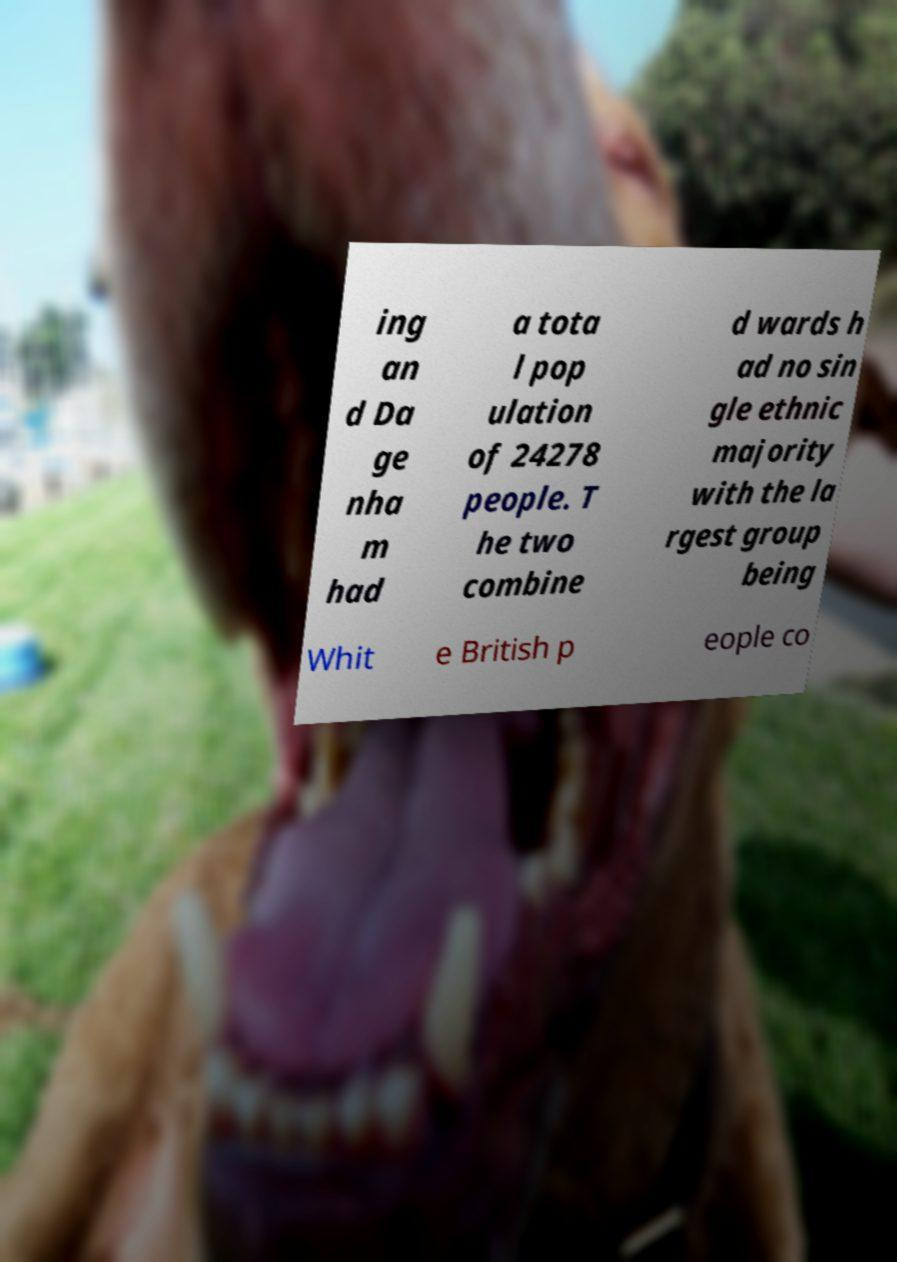There's text embedded in this image that I need extracted. Can you transcribe it verbatim? ing an d Da ge nha m had a tota l pop ulation of 24278 people. T he two combine d wards h ad no sin gle ethnic majority with the la rgest group being Whit e British p eople co 